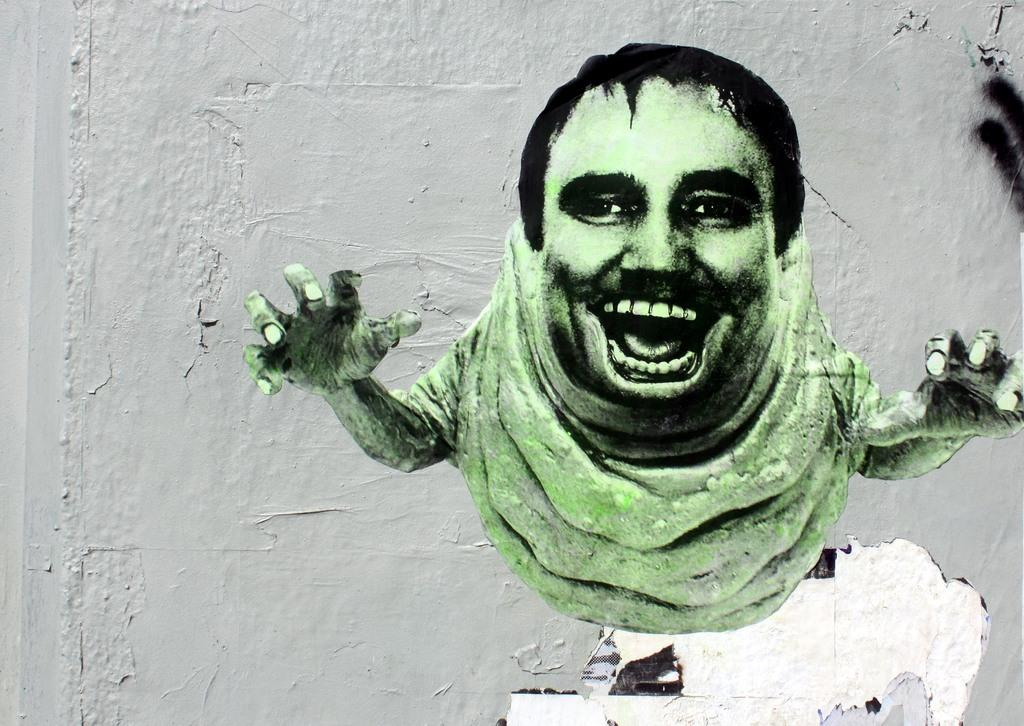What is one of the main features in the image? There is a wall in the image. Can you describe the presence of any living beings in the image? There is a person in the image. How many servants are attending to the person in the image? There is no mention of servants in the image; only a person and a wall are present. What day of the week is depicted in the image? The day of the week is not mentioned or depicted in the image. 